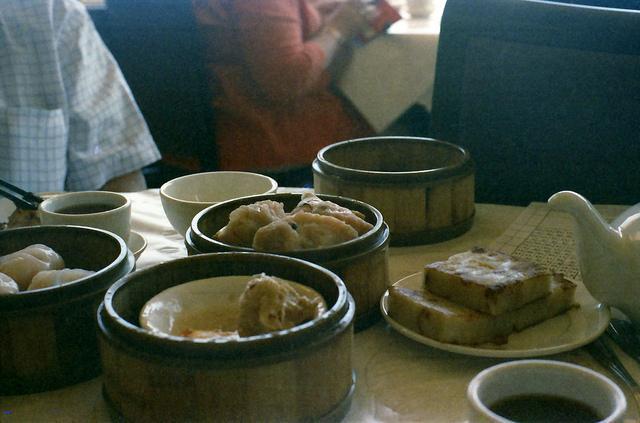How many chairs are visible?
Give a very brief answer. 2. How many cakes are there?
Give a very brief answer. 1. How many cups are there?
Give a very brief answer. 3. How many dining tables are there?
Give a very brief answer. 2. How many people are in the photo?
Give a very brief answer. 2. How many bowls are visible?
Give a very brief answer. 6. How many black cars are driving to the left of the bus?
Give a very brief answer. 0. 